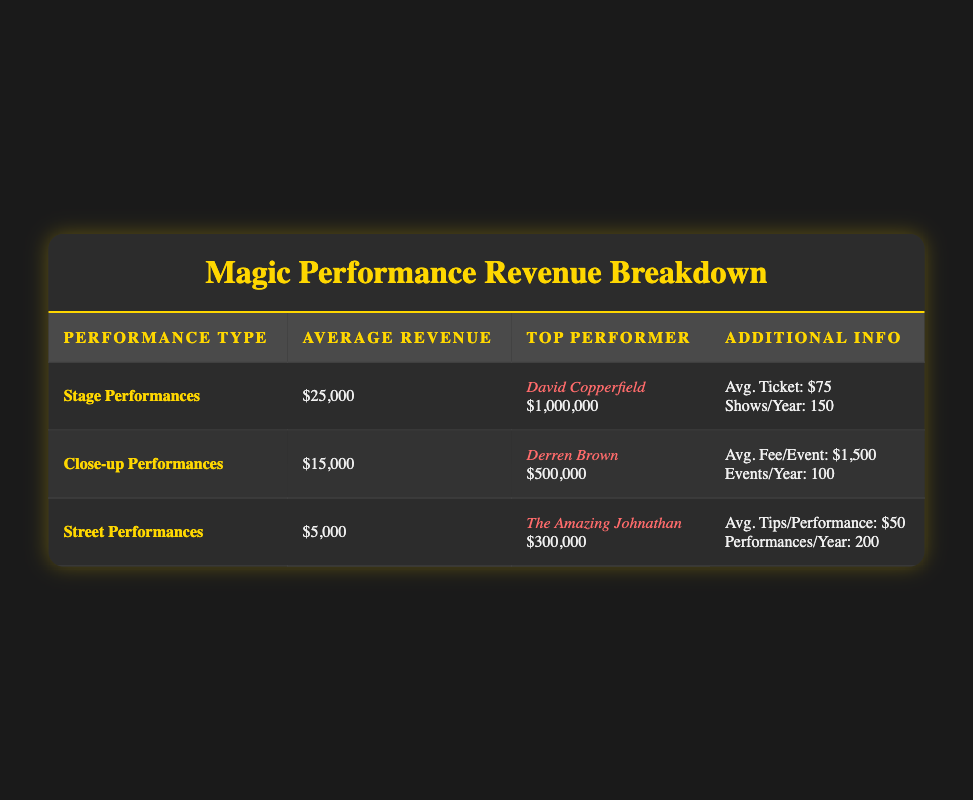What is the average revenue from stage performances? The table lists the average revenue for stage performances as $25,000, so we can retrieve it directly from the corresponding row in the table.
Answer: 25000 Who is the top performer in close-up performances? By examining the close-up performances row, we see that the top performer is Derren Brown, which is explicitly mentioned in the table.
Answer: Derren Brown What is the total number of performances per year for street performances? From the table, street performances average 200 performances per year. Since there’s no need for further calculations, we can retrieve this value directly.
Answer: 200 Is the average ticket price for stage performances higher than the average fee per event for close-up performances? The average ticket price for stage performances is $75, while the average fee per event for close-up performances is $1,500. Since $75 is less than $1,500, the statement is false.
Answer: False What is the combined average revenue from all types of performances? To calculate the combined average revenue, we sum the average revenues for all performance types: $25,000 (stage) + $15,000 (close-up) + $5,000 (street) = $45,000. Then, we divide by the number of performance types, which is 3: $45,000 / 3 = $15,000.
Answer: 15000 How much higher is the top performer's revenue in stage performances compared to that in street performances? The top performer for stage performances, David Copperfield, has a revenue of $1,000,000, while the top performer for street performances, The Amazing Johnathan, has a revenue of $300,000. To find the difference, we subtract $300,000 from $1,000,000, resulting in $700,000.
Answer: 700000 Are average tips for street performances more than average ticket prices for stage performances? The average tips per performance for street performances is $50, while the average ticket price for stage performances is $75. Since $50 is less than $75, the answer is no.
Answer: False Who has a higher average revenue, stage performers or close-up performers? The average revenue for stage performances is $25,000 and for close-up performances is $15,000. Since $25,000 is greater than $15,000, stage performers have a higher average revenue.
Answer: Stage performers 